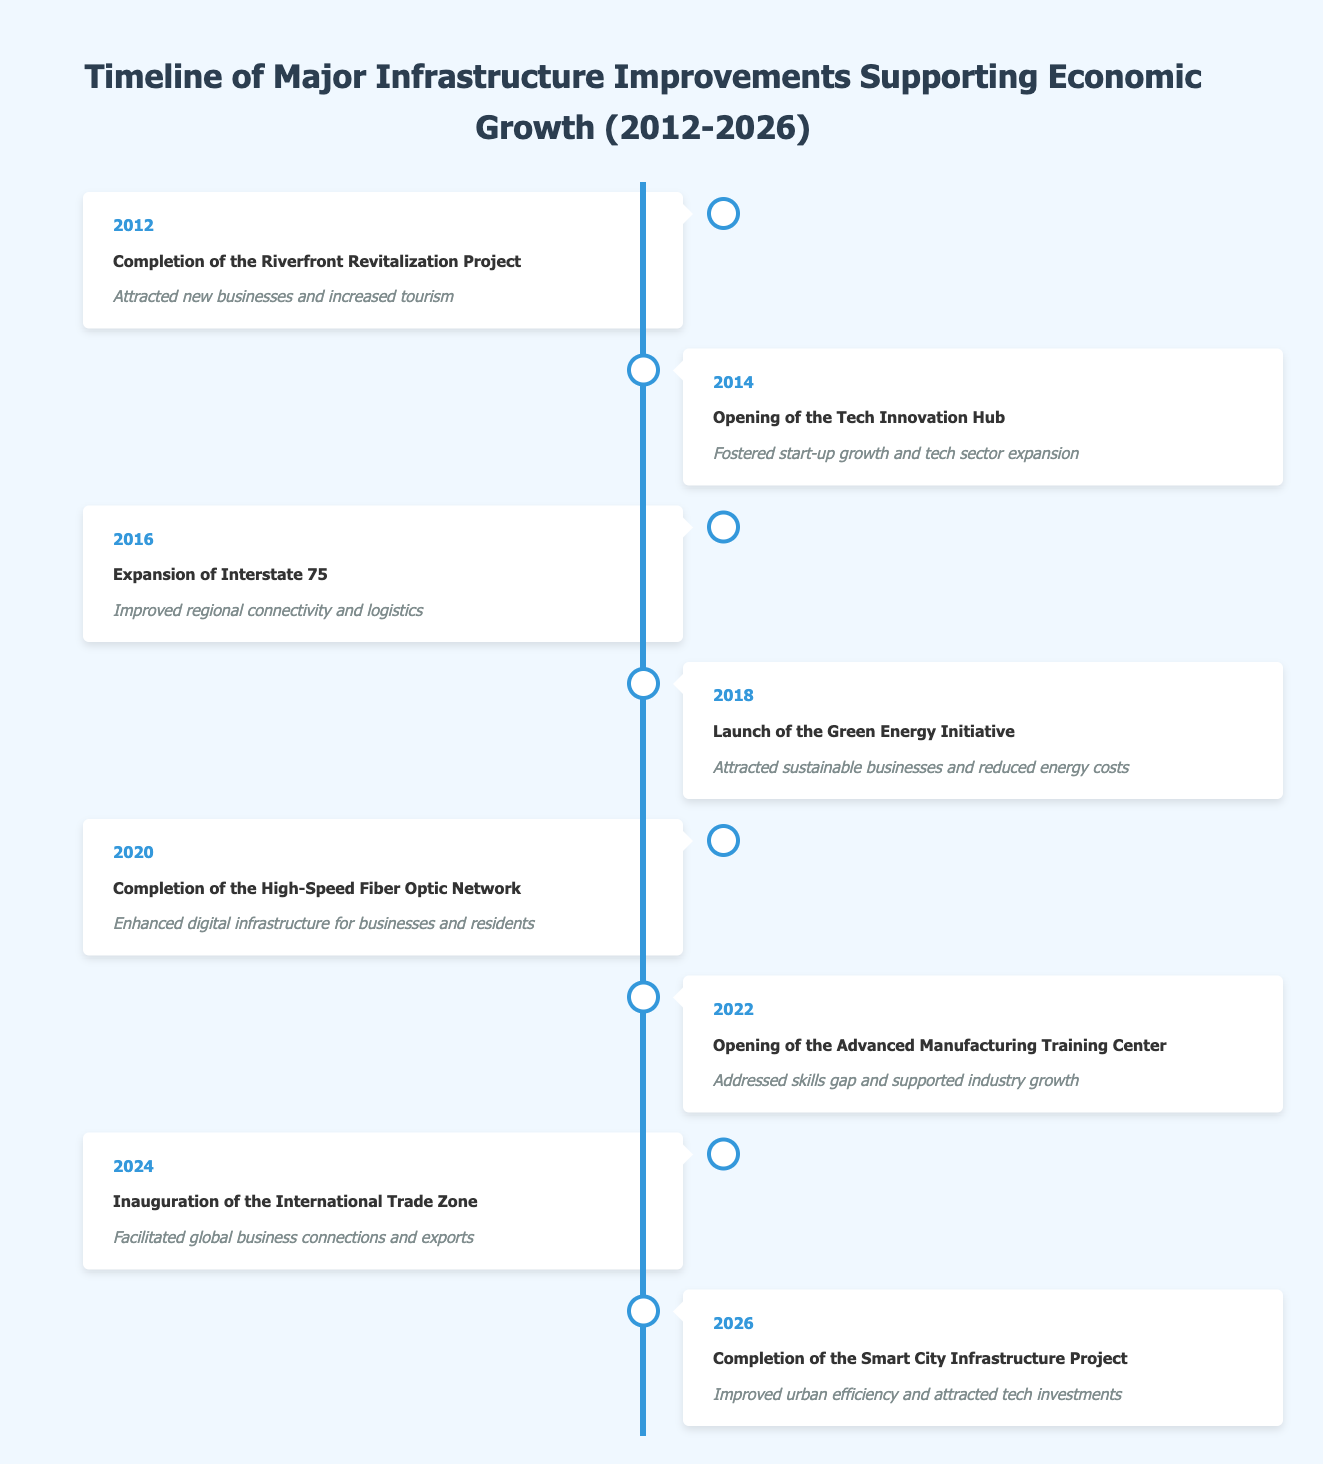What event marked the beginning of the timeline? The first event in the timeline is the completion of the Riverfront Revitalization Project in 2012. This is indicated as the earliest entry in the table.
Answer: Completion of the Riverfront Revitalization Project What was the impact of the Tech Innovation Hub? The opening of the Tech Innovation Hub in 2014 led to fostered start-up growth and tech sector expansion. This impact is directly associated with this specific event in the table.
Answer: Fostered start-up growth and tech sector expansion In which year did the International Trade Zone inaugurate? According to the timeline, the International Trade Zone was inaugurated in 2024. This is mentioned specifically in the table.
Answer: 2024 List all events that occurred from 2016 to 2020. The events occurring from 2016 to 2020 include: 2016 - Expansion of Interstate 75; 2018 - Launch of the Green Energy Initiative; 2020 - Completion of the High-Speed Fiber Optic Network. These years are within the specified range, and I gathered the information directly from the years listed in the table.
Answer: Expansion of Interstate 75, Launch of the Green Energy Initiative, Completion of the High-Speed Fiber Optic Network Did the Smart City Infrastructure Project happen before or after the International Trade Zone? The completion of the Smart City Infrastructure Project occurred in 2026, while the International Trade Zone was inaugurated in 2024. This indicates that the Smart City Infrastructure Project happened after the International Trade Zone.
Answer: After What is the total number of events listed in the timeline? There are a total of 8 events in the timeline, as each individual entry represents a distinct event. Counting the entries from 2012 to 2026 confirms this total.
Answer: 8 What impact did the High-Speed Fiber Optic Network have? The High-Speed Fiber Optic Network completed in 2020 enhanced digital infrastructure for businesses and residents, as stated in the table.
Answer: Enhanced digital infrastructure for businesses and residents Which event had the earliest impact related to tourism? The earliest event related to tourism was the completion of the Riverfront Revitalization Project in 2012, which attracted new businesses and increased tourism. This information can be identified as the first event in the timeline with a tourism-related impact.
Answer: Completion of the Riverfront Revitalization Project How many years passed between the completion of the Riverfront Revitalization Project and the opening of the Advanced Manufacturing Training Center? The Riverfront Revitalization Project was completed in 2012, and the Advanced Manufacturing Training Center opened in 2022. To find the years between, we calculate 2022 - 2012 = 10 years. Therefore, there were 10 years between these two events, as derived from the years.
Answer: 10 years 